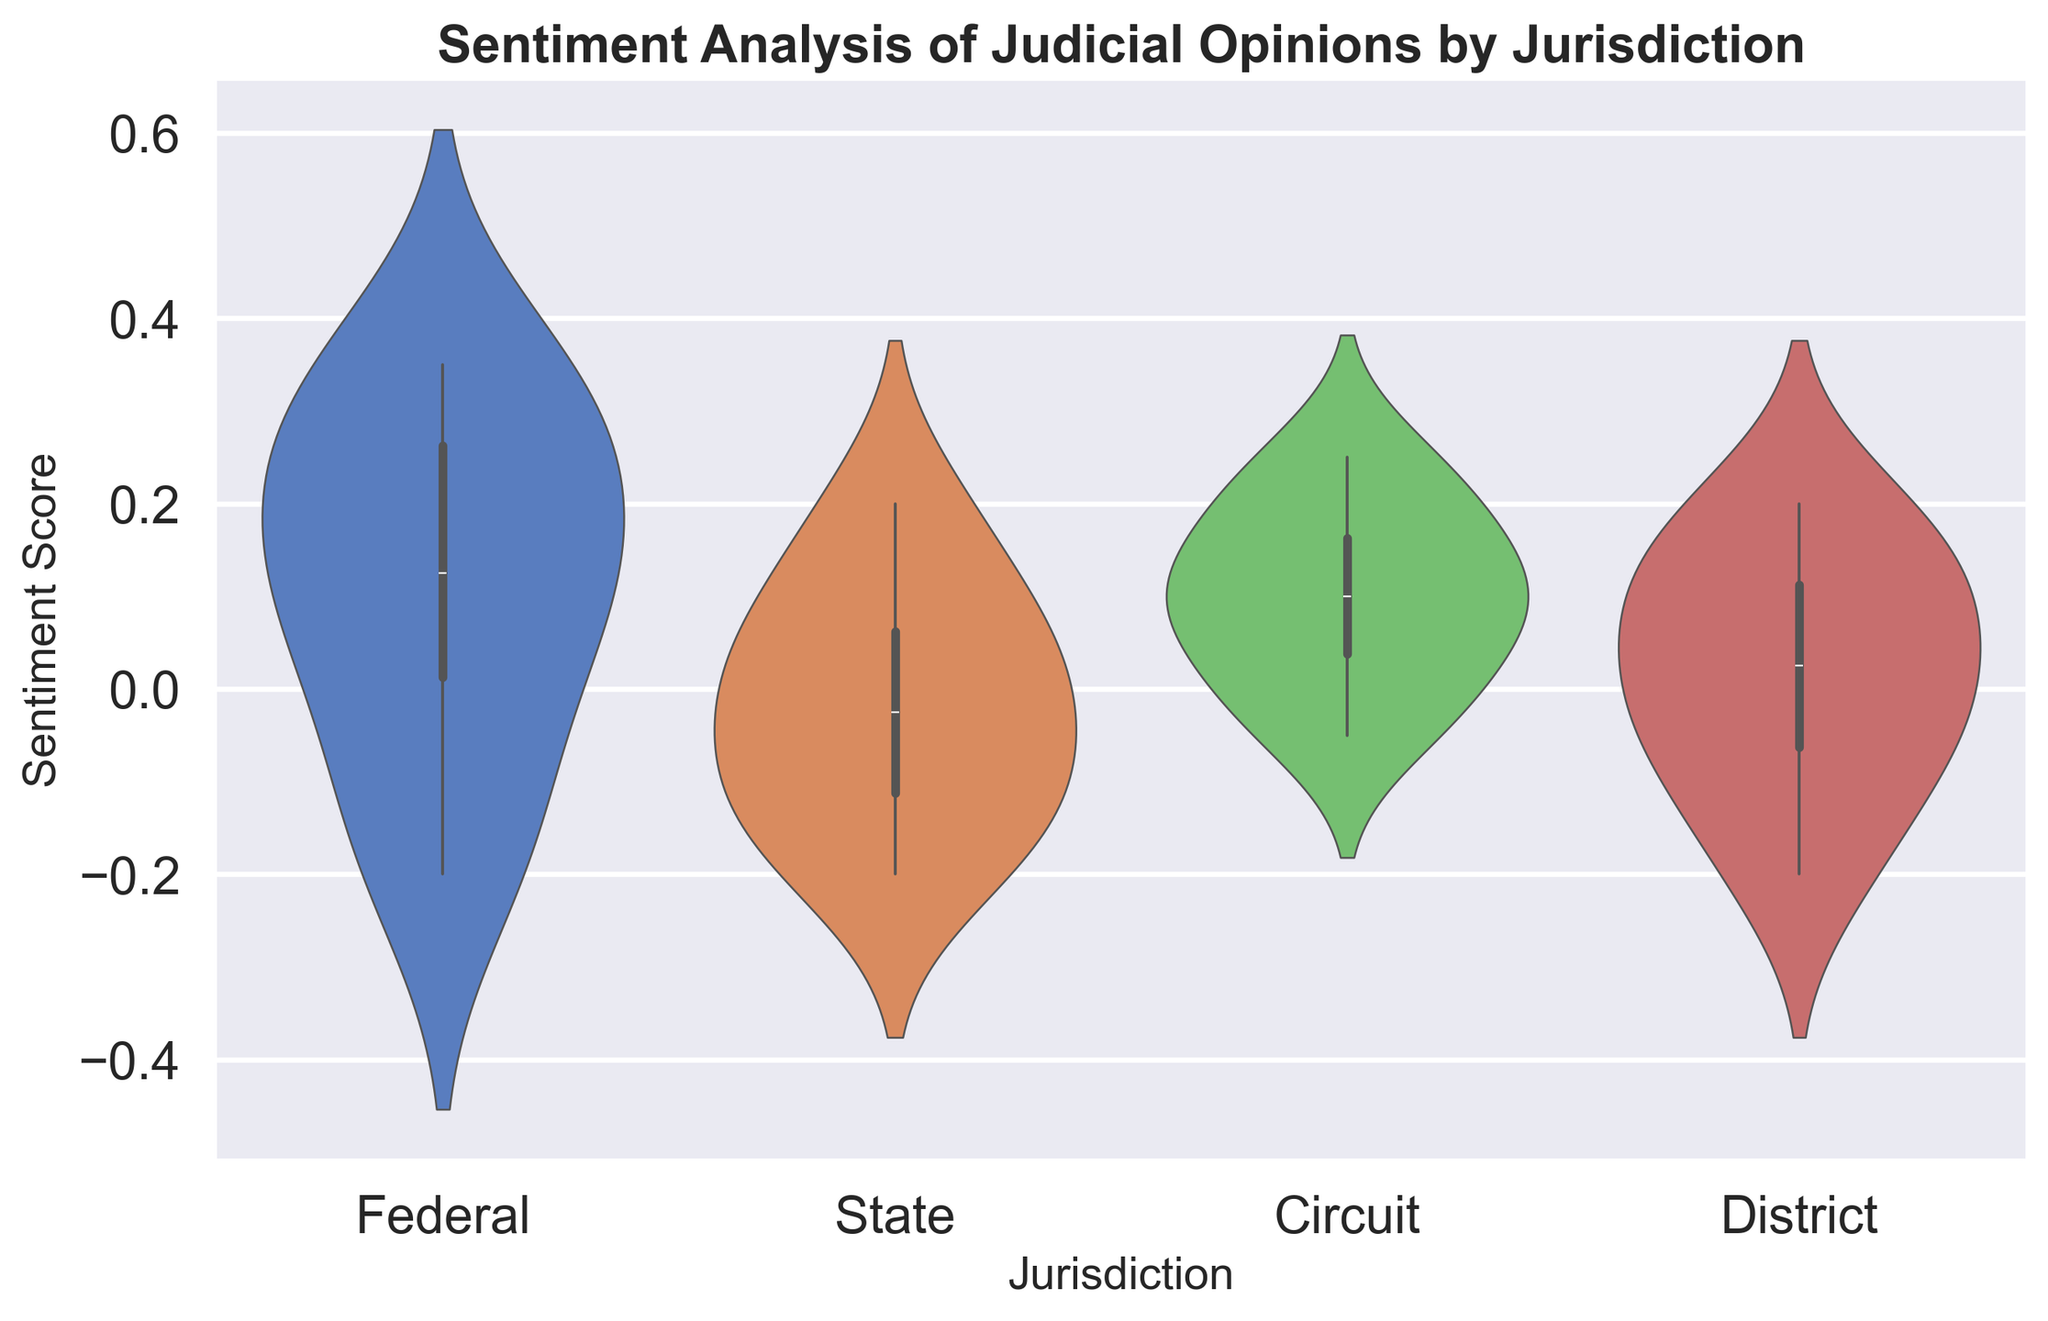What is the median sentiment score for the Federal jurisdiction? To find the median sentiment score for the Federal jurisdiction, we need to arrange the scores in ascending order: -0.2, -0.1, 0.05, 0.1, 0.15, 0.25, 0.3, 0.35. With 8 data points, the median is the average of the 4th and 5th values: (0.1 + 0.15) / 2 = 0.125
Answer: 0.125 Which jurisdiction has the highest median sentiment score? We need to compare the median sentiment scores of all jurisdictions. The medians are:
- Federal: 0.125
- State: 0.025
- Circuit: 0.1
- District: 0.0
Thus, the Federal jurisdiction has the highest median sentiment score
Answer: Federal Which jurisdiction shows the highest concentration of positive sentiment scores? To determine the highest concentration of positive sentiment scores, we look at the width and density of the violin plots above the zero line. The Federal jurisdiction’s plot is wider and denser in the positive range compared to others
Answer: Federal Is the spread of sentiment scores larger for State or District jurisdictions? To compare the spread of sentiment scores, we can look at the width of the respective violin plots. The State plot shows a wider range from approximately -0.2 to 0.2 compared to the District plot, which ranges from approximately -0.2 to 0.2. Both have the same range, but the visual density and distribution might indicate nuanced differences
Answer: Both have similar spread What is the interquartile range (IQR) for the State jurisdiction? The IQR is the difference between the first (Q1) and third quartiles (Q3). For the State jurisdiction, we first order the scores: -0.2, -0.15, -0.1, -0.05, 0.0, 0.05, 0.1, 0.2. Q1 is between -0.1 and -0.05 ((-0.1 + -0.05)/2 = -0.075), and Q3 is between 0.05 and 0.1 ((0.05 + 0.1)/2 = 0.075). The IQR is 0.075 - (-0.075) = 0.15
Answer: 0.15 